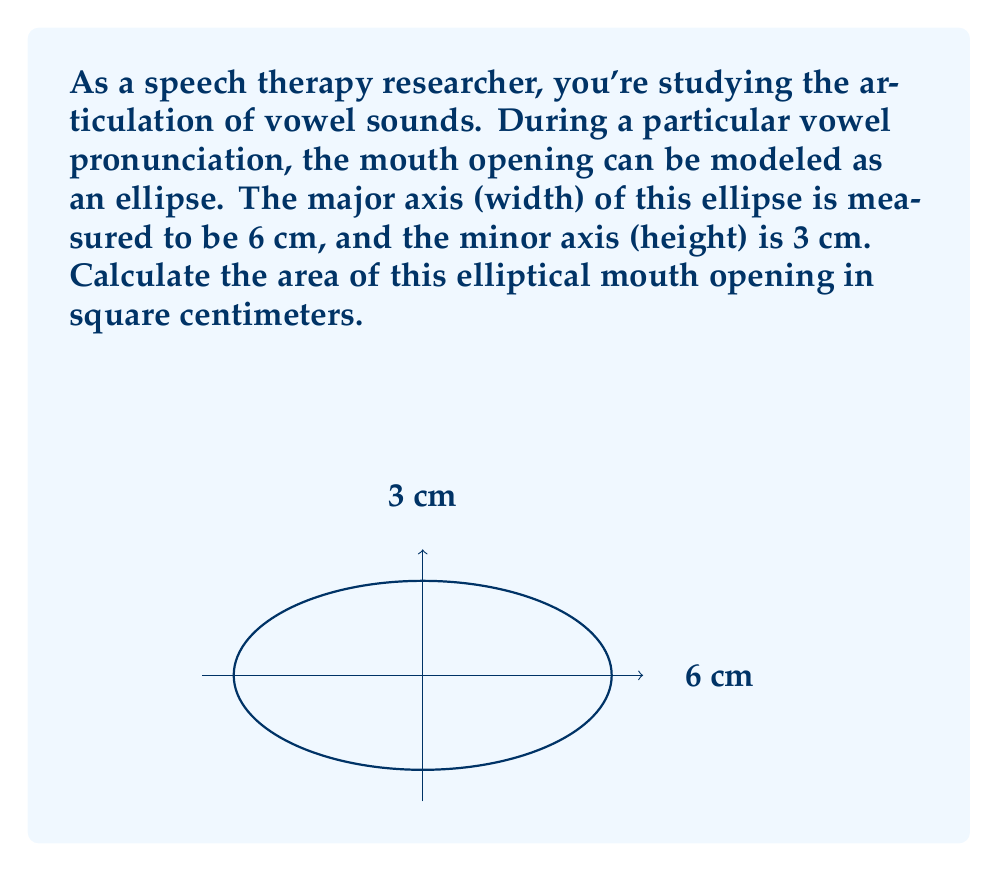Can you solve this math problem? Let's approach this step-by-step:

1) The formula for the area of an ellipse is:

   $$A = \pi ab$$

   where $a$ is the length of the semi-major axis and $b$ is the length of the semi-minor axis.

2) In this case:
   - The major axis (width) is 6 cm, so $a = 6/2 = 3$ cm
   - The minor axis (height) is 3 cm, so $b = 3/2 = 1.5$ cm

3) Substituting these values into the formula:

   $$A = \pi (3)(1.5)$$

4) Simplify:
   $$A = 4.5\pi$$

5) If we need to give a decimal approximation:
   $$A \approx 4.5 * 3.14159 \approx 14.13706$$

Therefore, the area of the elliptical mouth opening is $4.5\pi$ square centimeters, or approximately 14.14 cm².
Answer: $4.5\pi$ cm² (or approximately 14.14 cm²) 